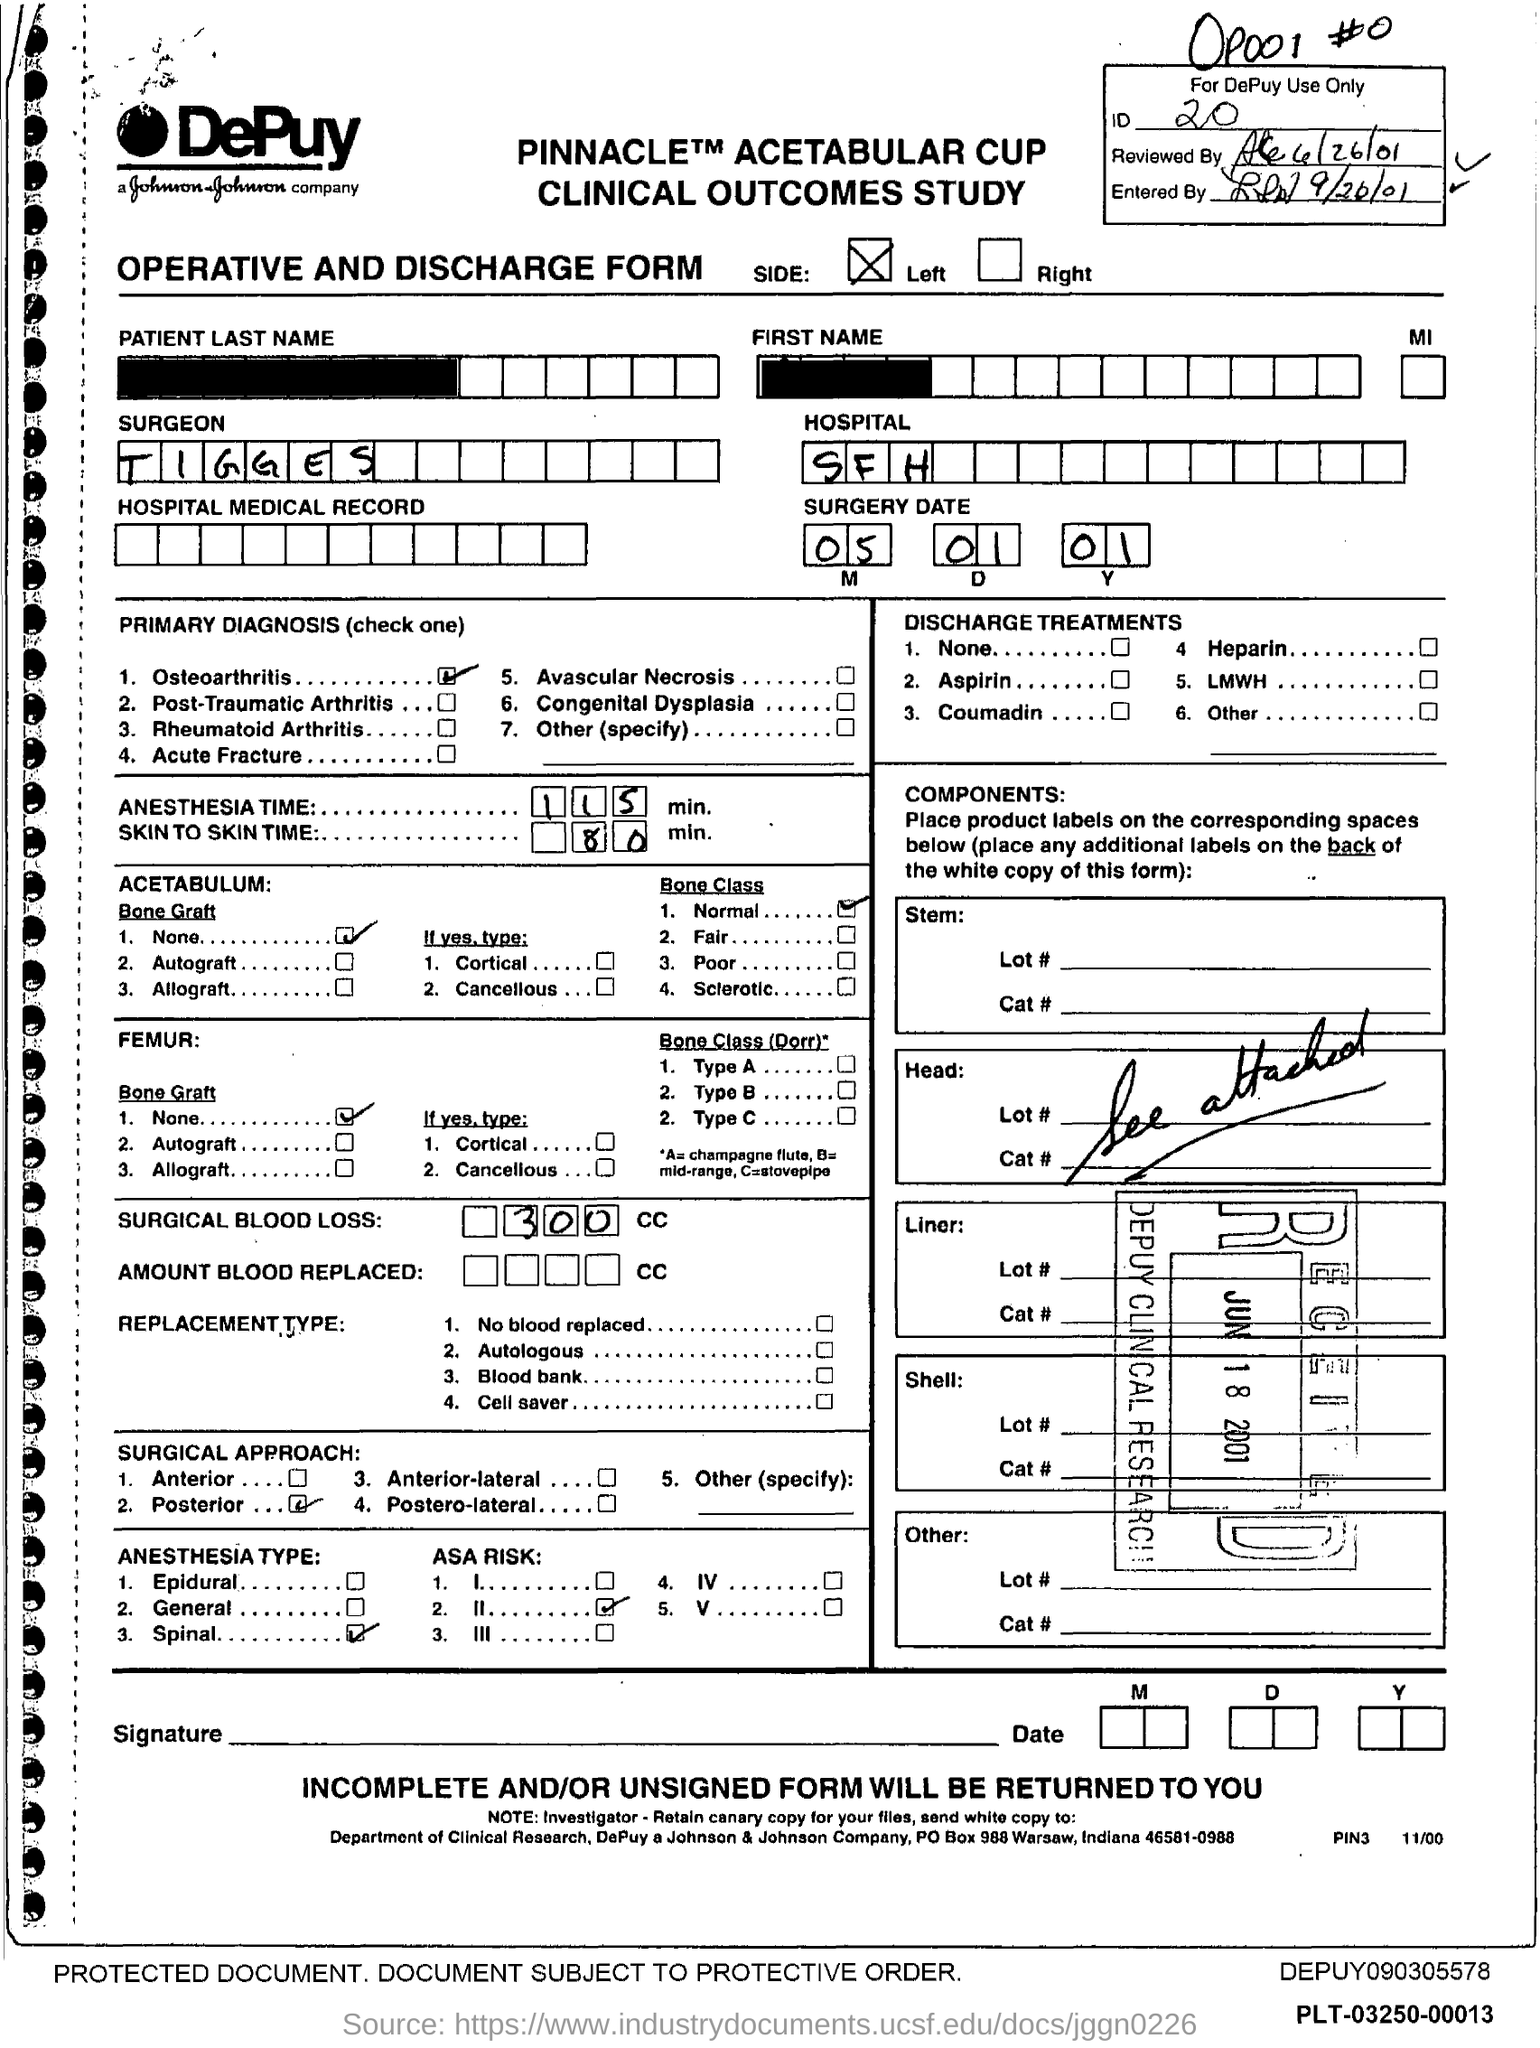Highlight a few significant elements in this photo. The primary diagnosis for the surgery is osteoarthritis. The ID mentioned in the form is 20. The surgical approach used in the procedure is the posterior approach. The amount of surgical blood loss is 300.. The anesthesia time for the surgery is 115 minutes. 